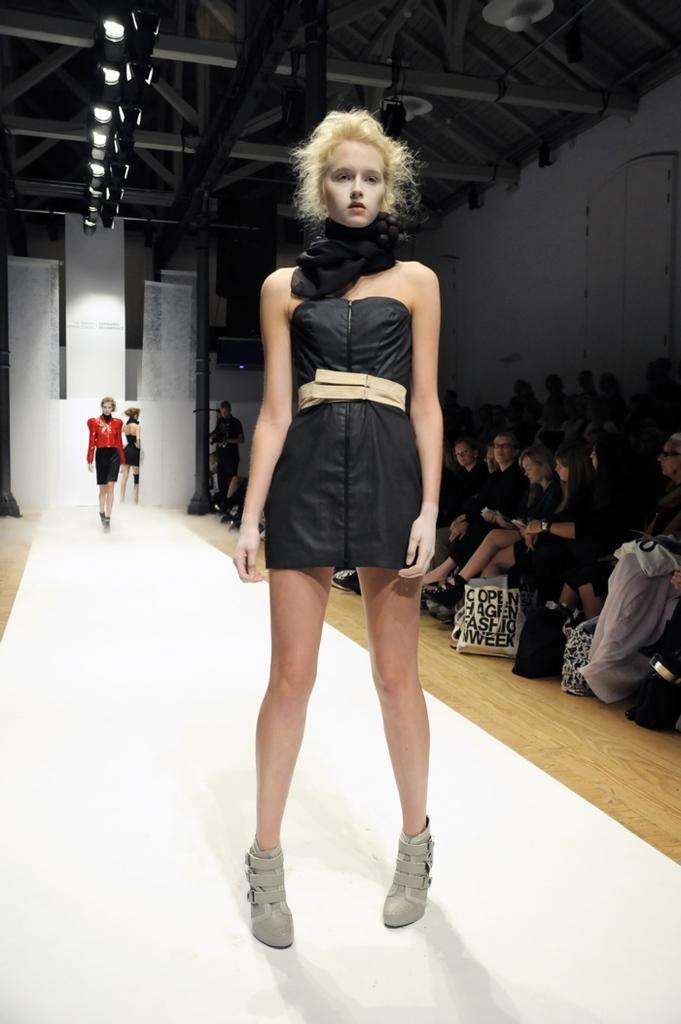Please provide a concise description of this image. In this image there is a person standing on the ramp, and at the background there are two people walking on the ramp, lights, group of people sitting on the chairs. 